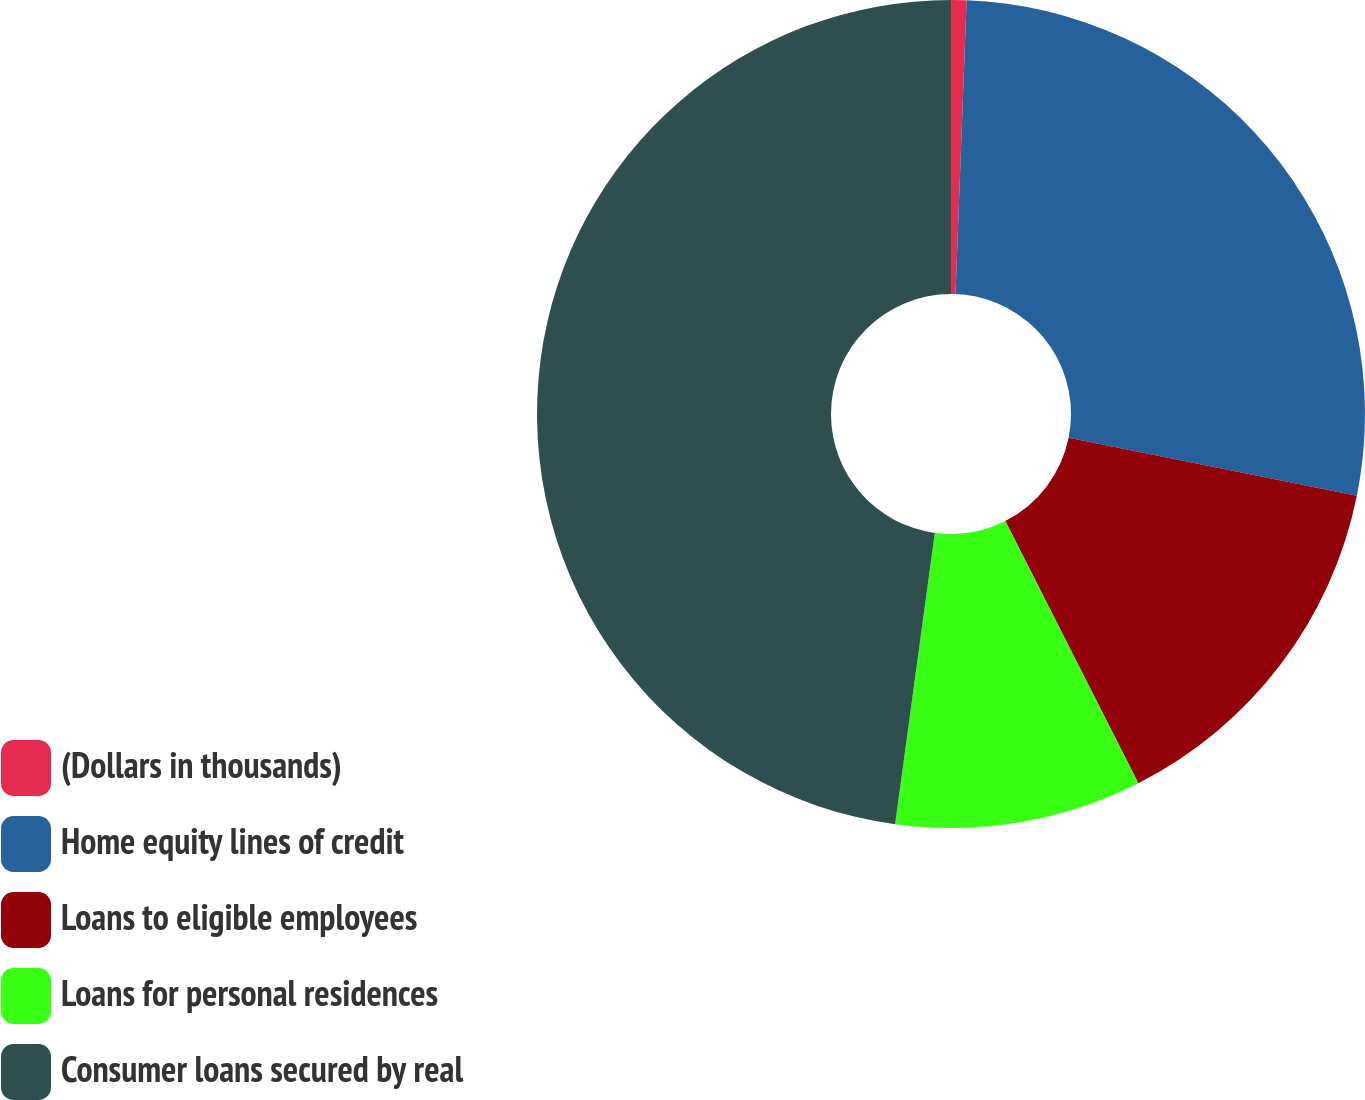Convert chart. <chart><loc_0><loc_0><loc_500><loc_500><pie_chart><fcel>(Dollars in thousands)<fcel>Home equity lines of credit<fcel>Loans to eligible employees<fcel>Loans for personal residences<fcel>Consumer loans secured by real<nl><fcel>0.6%<fcel>27.57%<fcel>14.36%<fcel>9.63%<fcel>47.85%<nl></chart> 